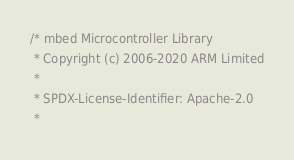Convert code to text. <code><loc_0><loc_0><loc_500><loc_500><_C_>/* mbed Microcontroller Library
 * Copyright (c) 2006-2020 ARM Limited
 *
 * SPDX-License-Identifier: Apache-2.0
 *</code> 